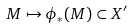Convert formula to latex. <formula><loc_0><loc_0><loc_500><loc_500>M \mapsto \phi _ { * } ( M ) \subset X ^ { \prime }</formula> 